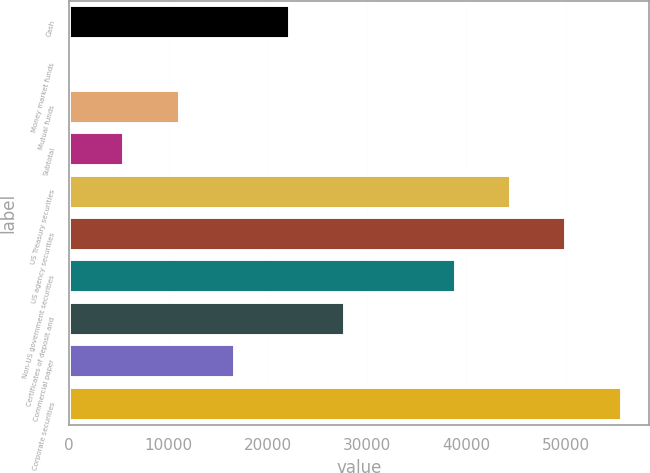Convert chart. <chart><loc_0><loc_0><loc_500><loc_500><bar_chart><fcel>Cash<fcel>Money market funds<fcel>Mutual funds<fcel>Subtotal<fcel>US Treasury securities<fcel>US agency securities<fcel>Non-US government securities<fcel>Certificates of deposit and<fcel>Commercial paper<fcel>Corporate securities<nl><fcel>22248.2<fcel>1.64<fcel>11124.9<fcel>5563.28<fcel>44494.8<fcel>50056.4<fcel>38933.1<fcel>27809.8<fcel>16686.6<fcel>55618<nl></chart> 